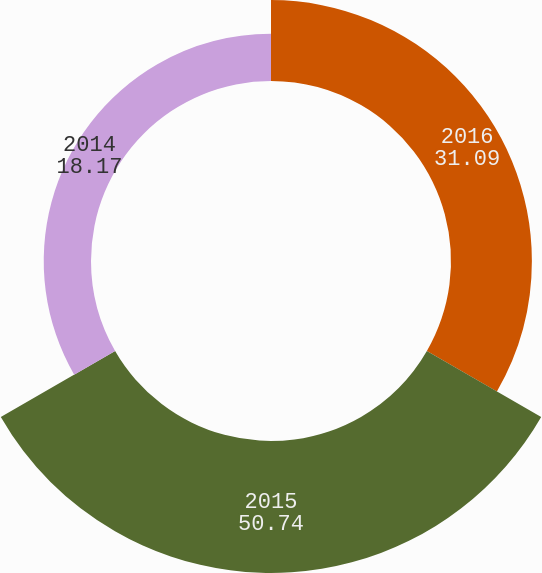<chart> <loc_0><loc_0><loc_500><loc_500><pie_chart><fcel>2016<fcel>2015<fcel>2014<nl><fcel>31.09%<fcel>50.74%<fcel>18.17%<nl></chart> 